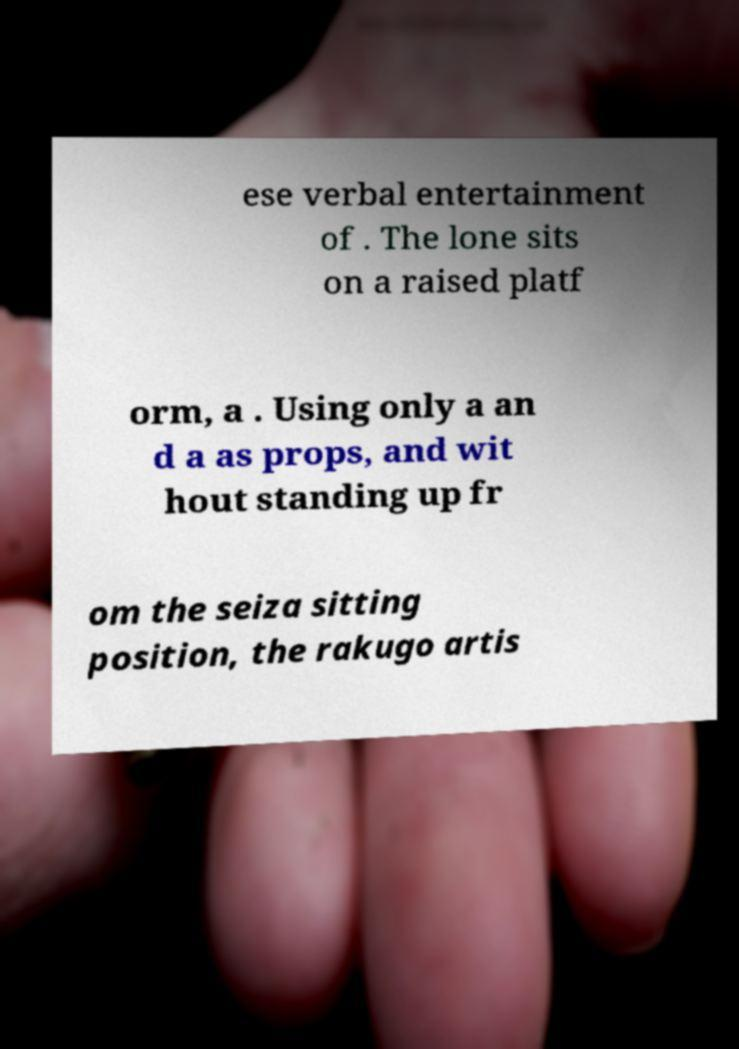Can you read and provide the text displayed in the image?This photo seems to have some interesting text. Can you extract and type it out for me? ese verbal entertainment of . The lone sits on a raised platf orm, a . Using only a an d a as props, and wit hout standing up fr om the seiza sitting position, the rakugo artis 